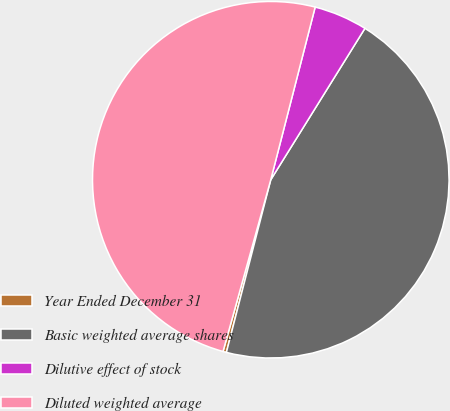Convert chart to OTSL. <chart><loc_0><loc_0><loc_500><loc_500><pie_chart><fcel>Year Ended December 31<fcel>Basic weighted average shares<fcel>Dilutive effect of stock<fcel>Diluted weighted average<nl><fcel>0.31%<fcel>45.15%<fcel>4.85%<fcel>49.69%<nl></chart> 